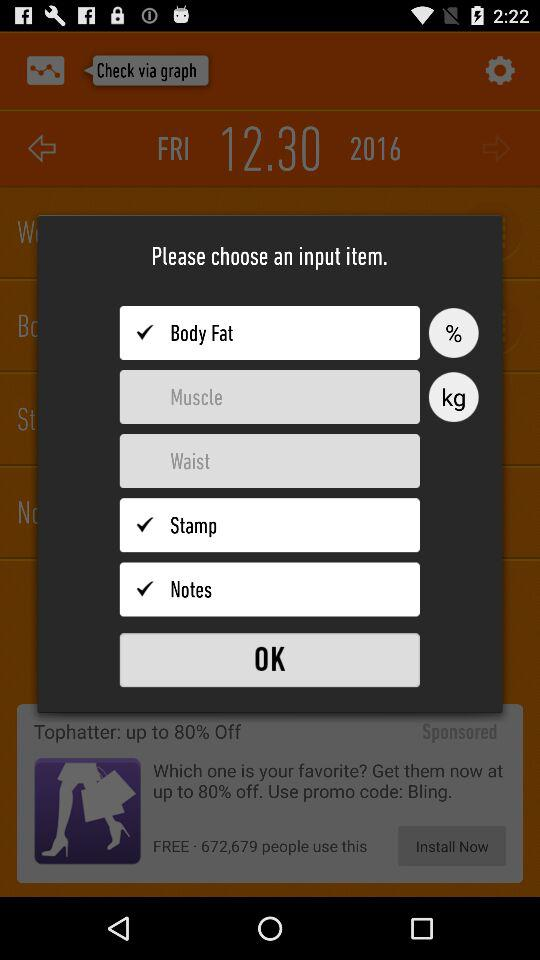How many input items are there?
Answer the question using a single word or phrase. 5 